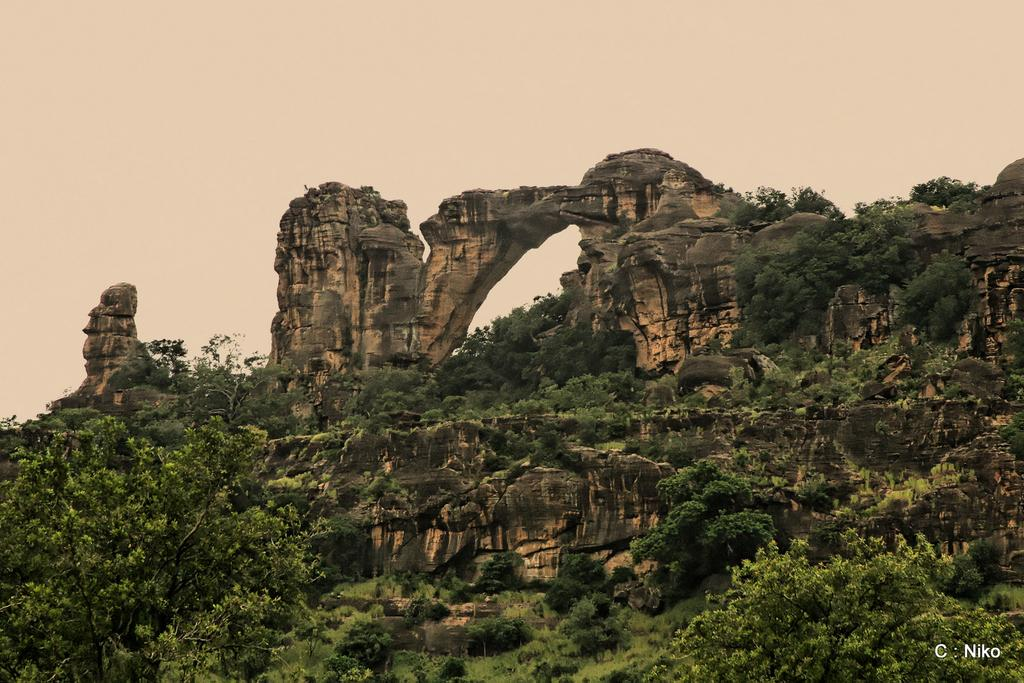What type of vegetation is present in the image? There are trees in the image. What is located above the trees in the image? There is a rock mountain above the trees. Where can you find text or an image in the image? There is text or an image in the right bottom corner of the image. What type of action is being performed by the quill in the image? There is no quill present in the image, so no action can be attributed to it. Can you describe the umbrella that is being held by the person in the image? There are no people or umbrellas present in the image. 